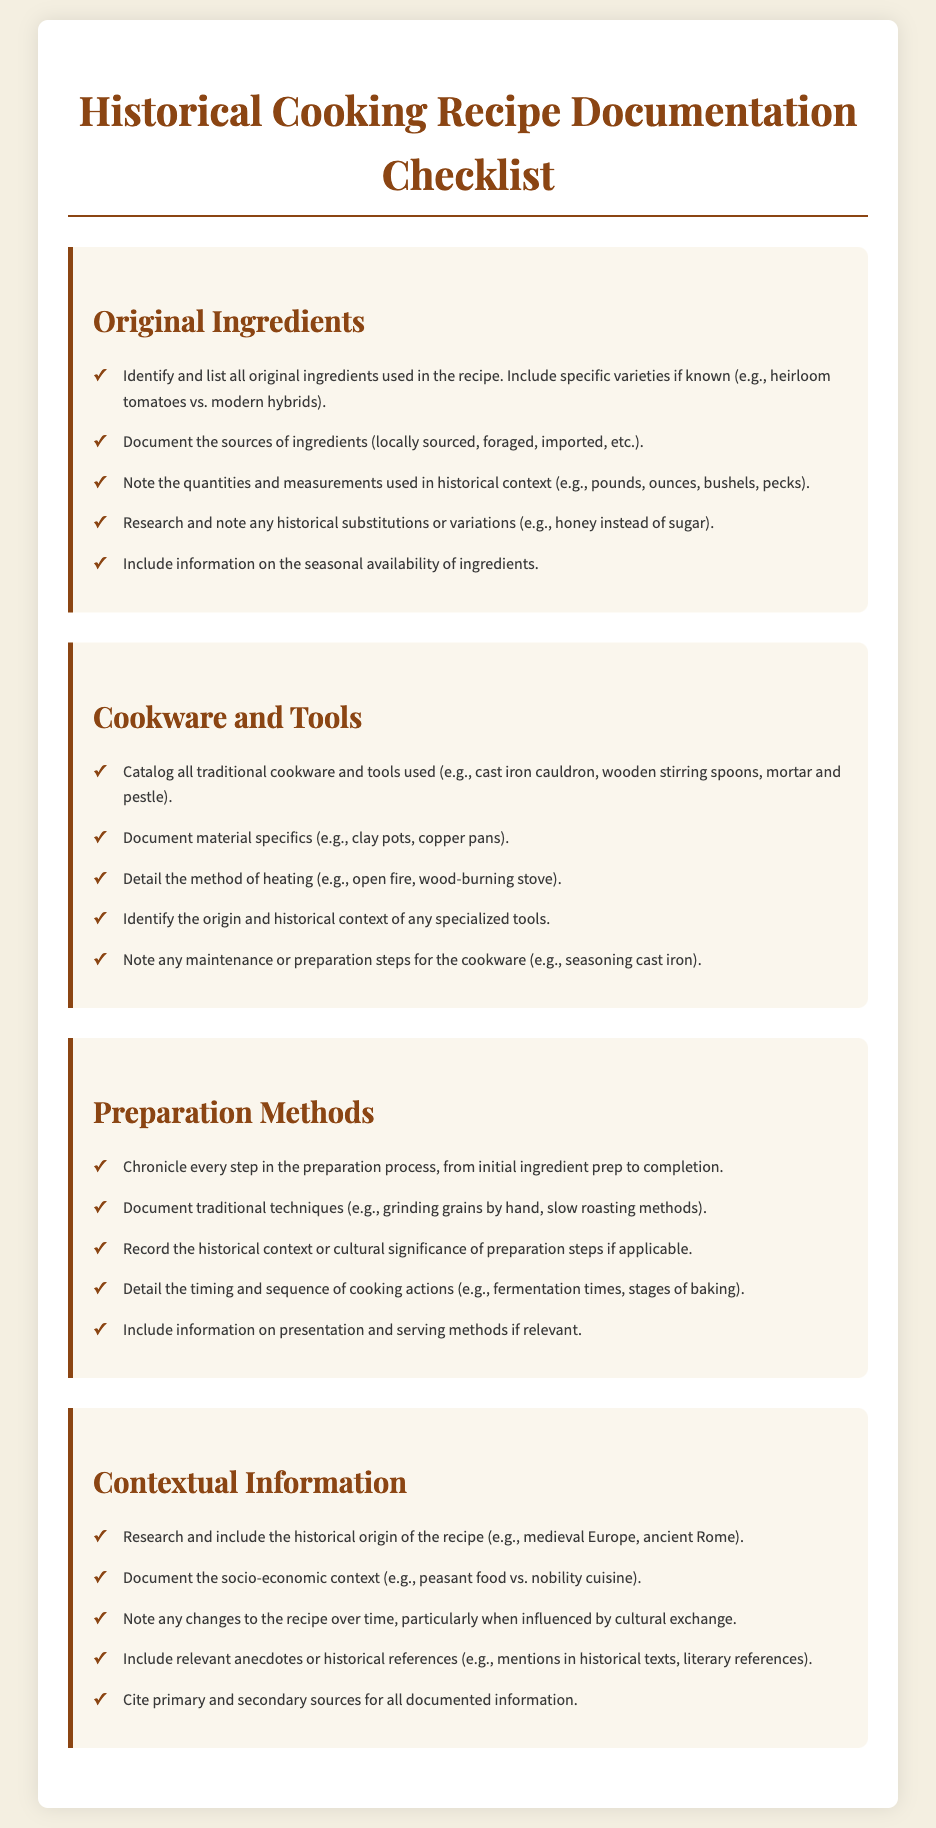What are the original ingredients? The section lists steps to identify and list all original ingredients used in the recipe.
Answer: Original ingredients What cookware is mentioned? The checklist invites documenting all traditional cookware and tools used.
Answer: Traditional cookware What heating method is specified? The document details the method of heating in the cookware and tools section.
Answer: Open fire What is an example of a traditional technique? The checklist seeks to document traditional techniques in the preparation methods section.
Answer: Grinding grains by hand How many sections are in the checklist? The document outlines four main sections related to historical cooking recipe documentation.
Answer: Four What type of context information is required? The contextual information outlines the need to research and include the historical origin of the recipe.
Answer: Historical origin What should be documented regarding ingredient sources? The original ingredients section emphasizes documenting sources of ingredients.
Answer: Sources of ingredients What is essential to include about seasoning? The cookware section calls for noting maintenance or preparation steps for the cookware.
Answer: Seasoning cast iron 